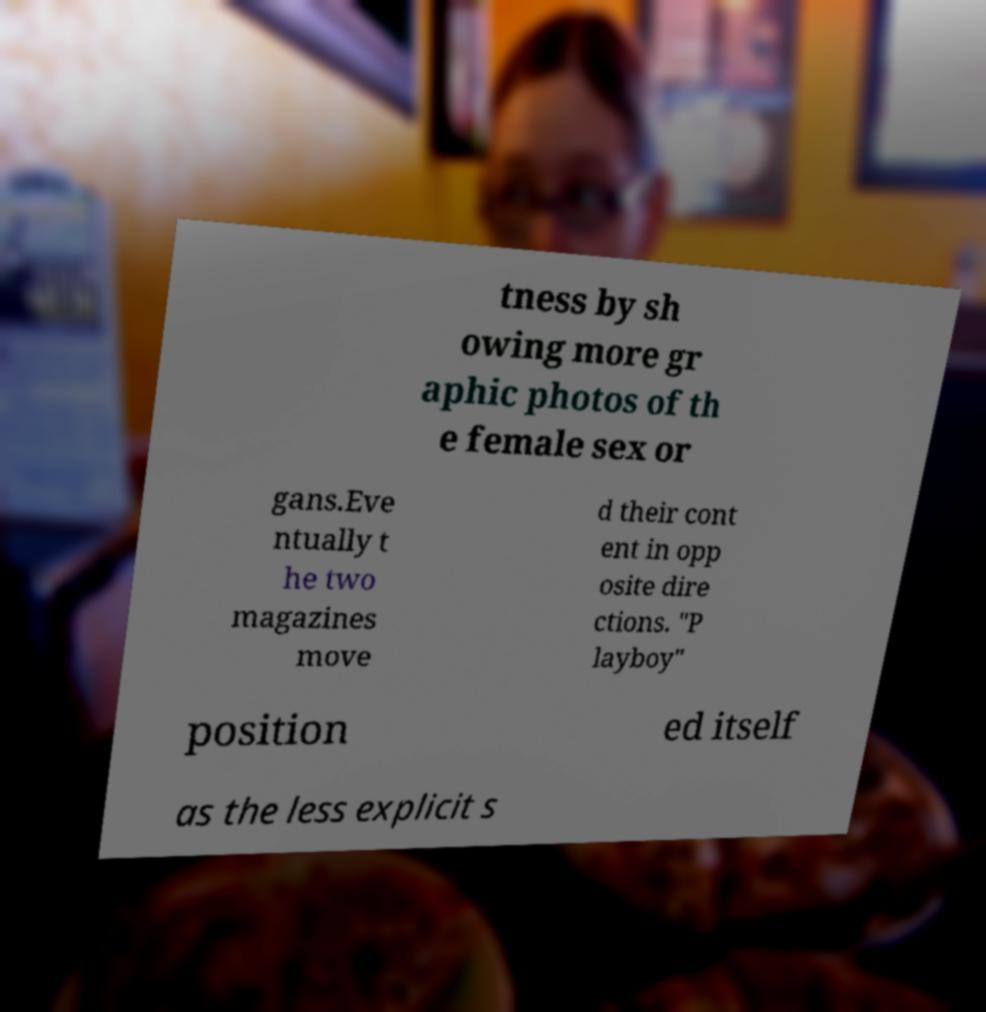Please read and relay the text visible in this image. What does it say? tness by sh owing more gr aphic photos of th e female sex or gans.Eve ntually t he two magazines move d their cont ent in opp osite dire ctions. "P layboy" position ed itself as the less explicit s 